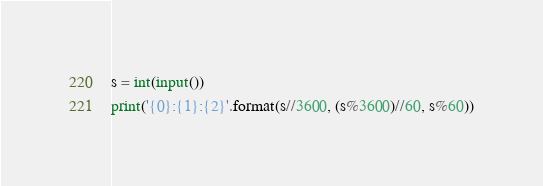Convert code to text. <code><loc_0><loc_0><loc_500><loc_500><_Python_>s = int(input())
print('{0}:{1}:{2}'.format(s//3600, (s%3600)//60, s%60))

</code> 